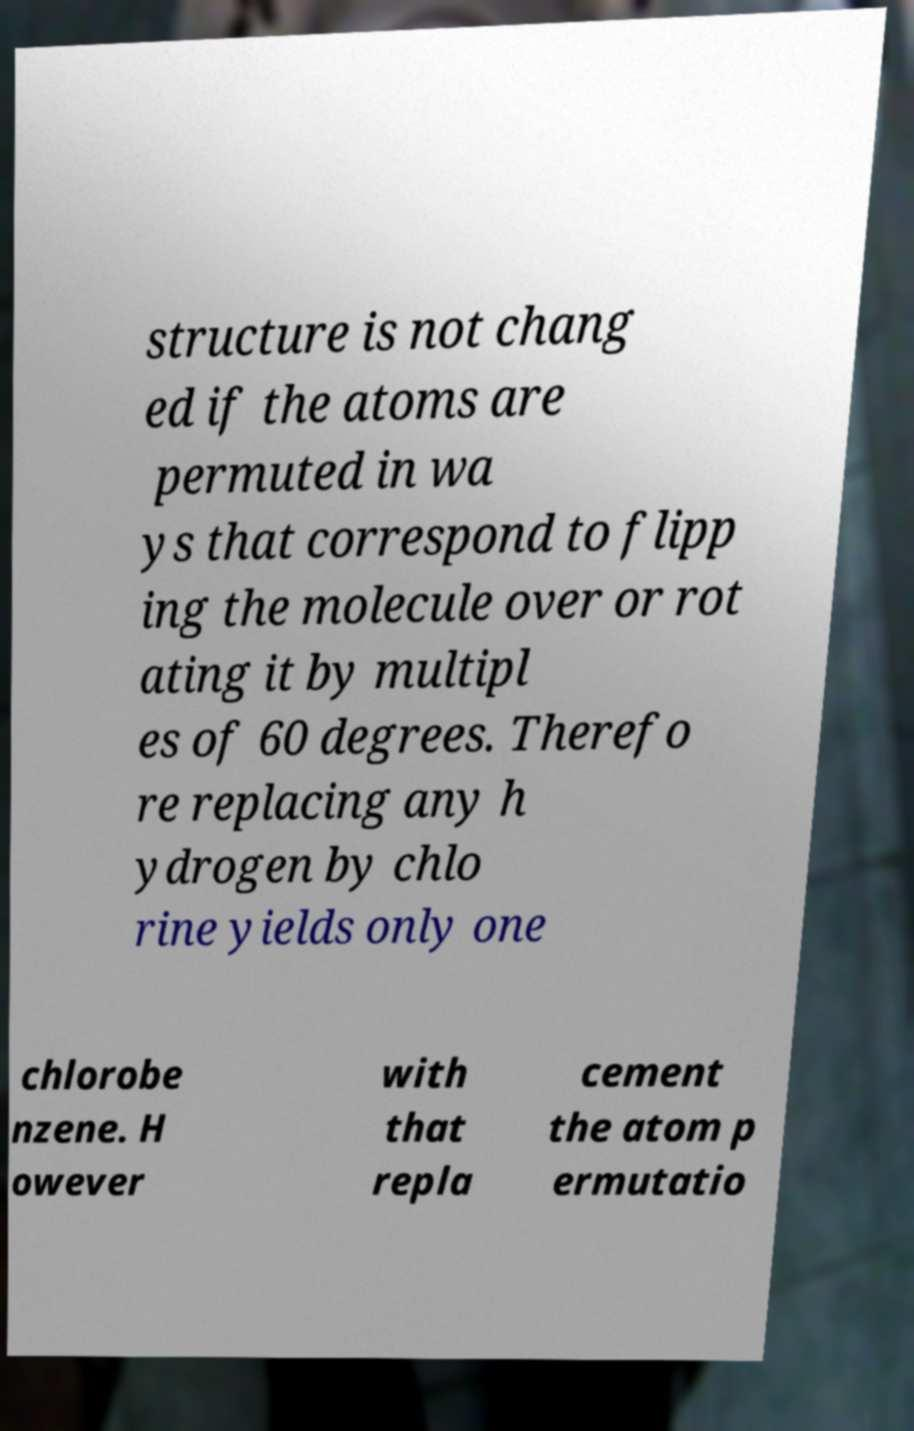I need the written content from this picture converted into text. Can you do that? structure is not chang ed if the atoms are permuted in wa ys that correspond to flipp ing the molecule over or rot ating it by multipl es of 60 degrees. Therefo re replacing any h ydrogen by chlo rine yields only one chlorobe nzene. H owever with that repla cement the atom p ermutatio 